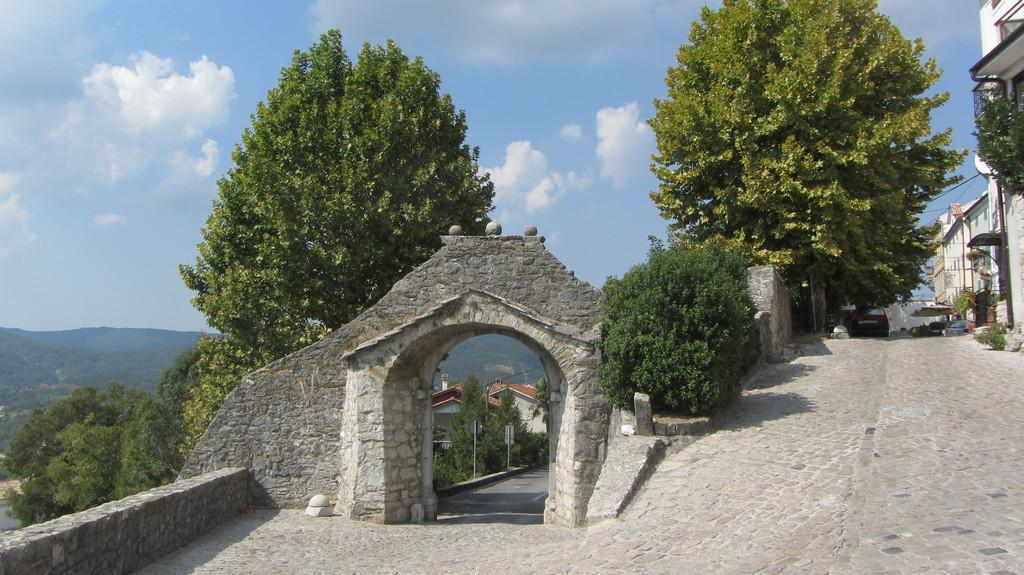What structure is located in the middle of the image? There is an arch in the middle of the image. What type of natural elements can be seen in the image? There are trees in the image. What type of man-made structures are on the right side of the image? There are buildings on the right side of the image. What is the condition of the sky in the image? The sky is cloudy in the image. What type of act is the queen performing in the image? There is no queen or act present in the image. What color is the silver object in the image? There is no silver object present in the image. 